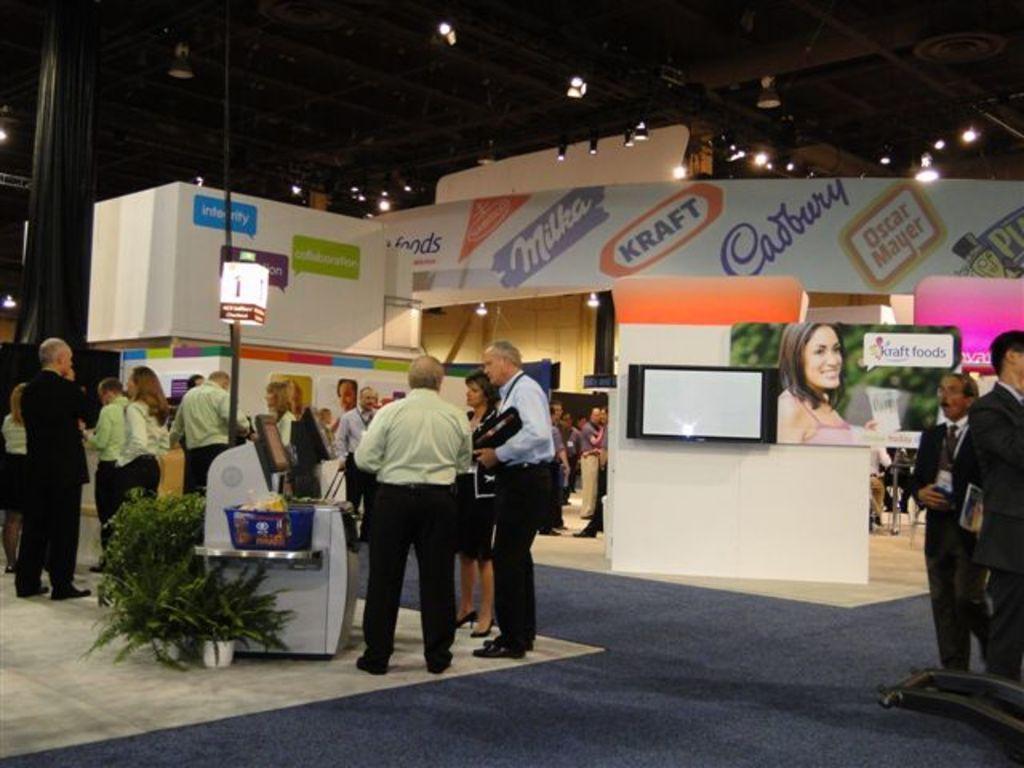Can you describe this image briefly? In the image we can see there are people standing, wearing clothes and they are wearing shoes. Here we can see plant pot, pole and lights. We can even see posters and text on it. We can see carpet and the floor. 